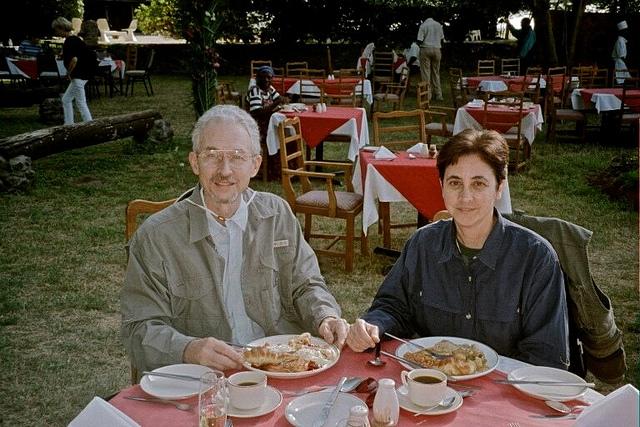Is there a lot of grass on the ground?
Concise answer only. Yes. Are these people having coffee with their meal?
Keep it brief. Yes. Is this a restaurant or a special event?
Give a very brief answer. Special event. What are the people eating?
Answer briefly. Pie. 